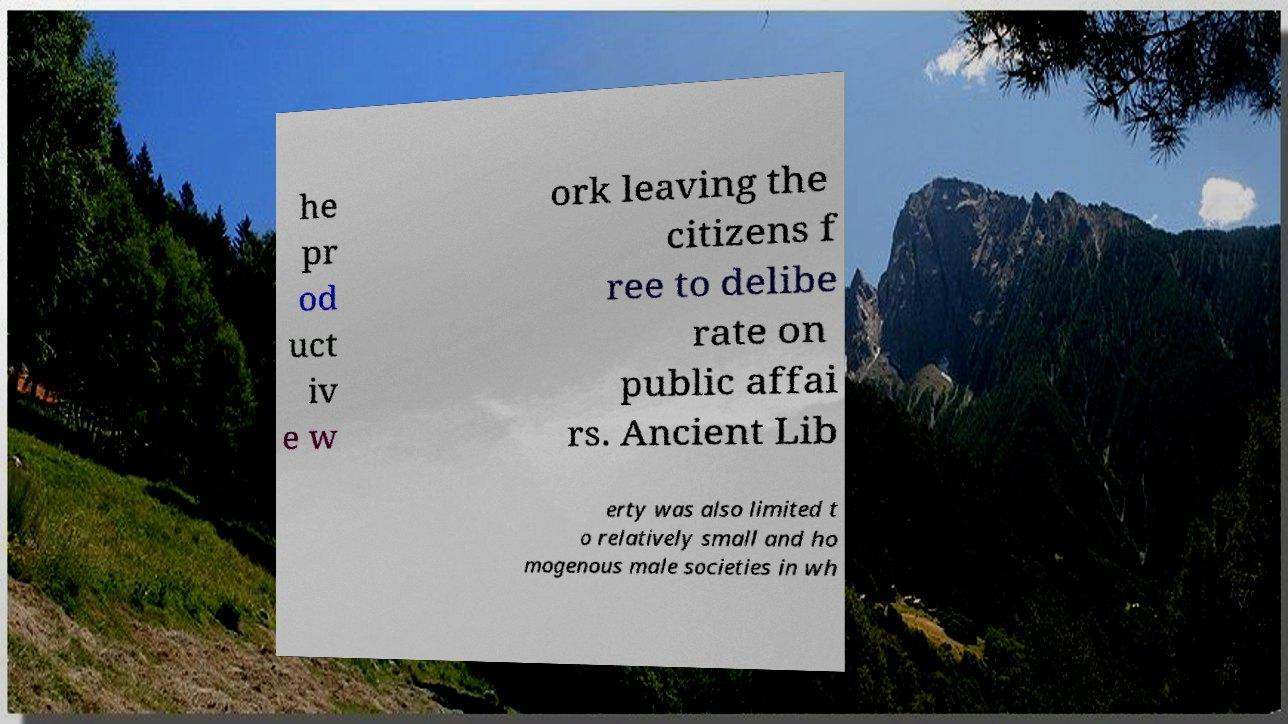There's text embedded in this image that I need extracted. Can you transcribe it verbatim? he pr od uct iv e w ork leaving the citizens f ree to delibe rate on public affai rs. Ancient Lib erty was also limited t o relatively small and ho mogenous male societies in wh 